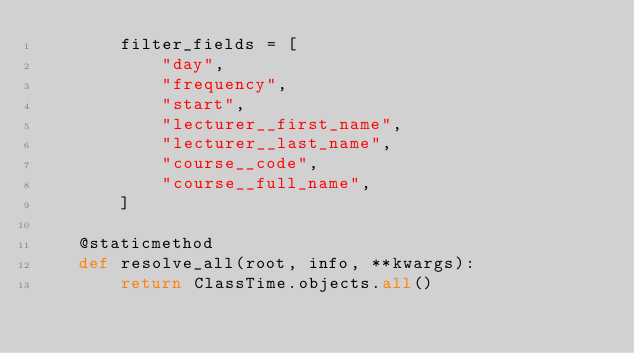<code> <loc_0><loc_0><loc_500><loc_500><_Python_>        filter_fields = [
            "day",
            "frequency",
            "start",
            "lecturer__first_name",
            "lecturer__last_name",
            "course__code",
            "course__full_name",
        ]

    @staticmethod
    def resolve_all(root, info, **kwargs):
        return ClassTime.objects.all()
</code> 